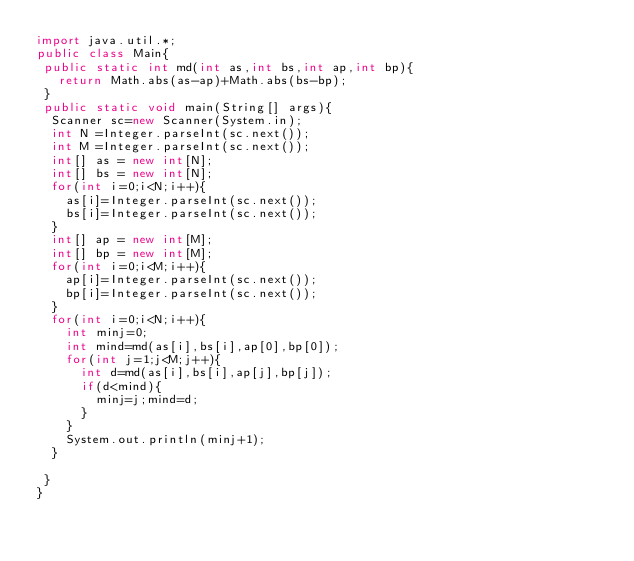Convert code to text. <code><loc_0><loc_0><loc_500><loc_500><_Java_>import java.util.*;
public class Main{
 public static int md(int as,int bs,int ap,int bp){
	 return Math.abs(as-ap)+Math.abs(bs-bp); 
 }
 public static void main(String[] args){
	Scanner sc=new Scanner(System.in);
	int N =Integer.parseInt(sc.next());
	int M =Integer.parseInt(sc.next());
	int[] as = new int[N];
	int[] bs = new int[N];
	for(int i=0;i<N;i++){
		as[i]=Integer.parseInt(sc.next());
		bs[i]=Integer.parseInt(sc.next());
	}
	int[] ap = new int[M];
	int[] bp = new int[M];
	for(int i=0;i<M;i++){
		ap[i]=Integer.parseInt(sc.next());
		bp[i]=Integer.parseInt(sc.next());
	}
	for(int i=0;i<N;i++){
		int minj=0;
		int mind=md(as[i],bs[i],ap[0],bp[0]);
		for(int j=1;j<M;j++){
			int d=md(as[i],bs[i],ap[j],bp[j]);
			if(d<mind){
				minj=j;mind=d;
			}
		}
		System.out.println(minj+1);
	}

 }
}
</code> 